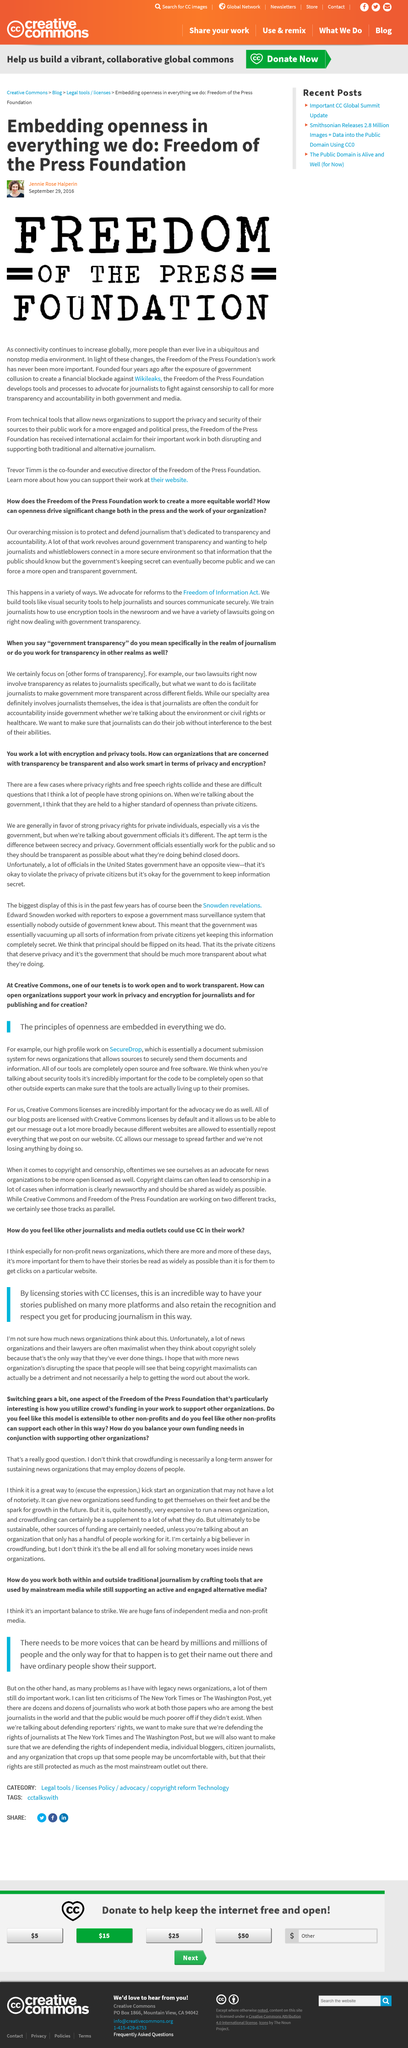Highlight a few significant elements in this photo. Independent and non-profit media are their objects of immense admiration and support. All tools offered by Creative Commons are open source and free software, and none of them require payment or purchase. You can have your stories published on various platforms by licensing them with Creative Commons (CC) licenses. Their specialty area is journalism, specifically in the field of investigative reporting. Non-profit news organizations are becoming increasingly prevalent in our society. 